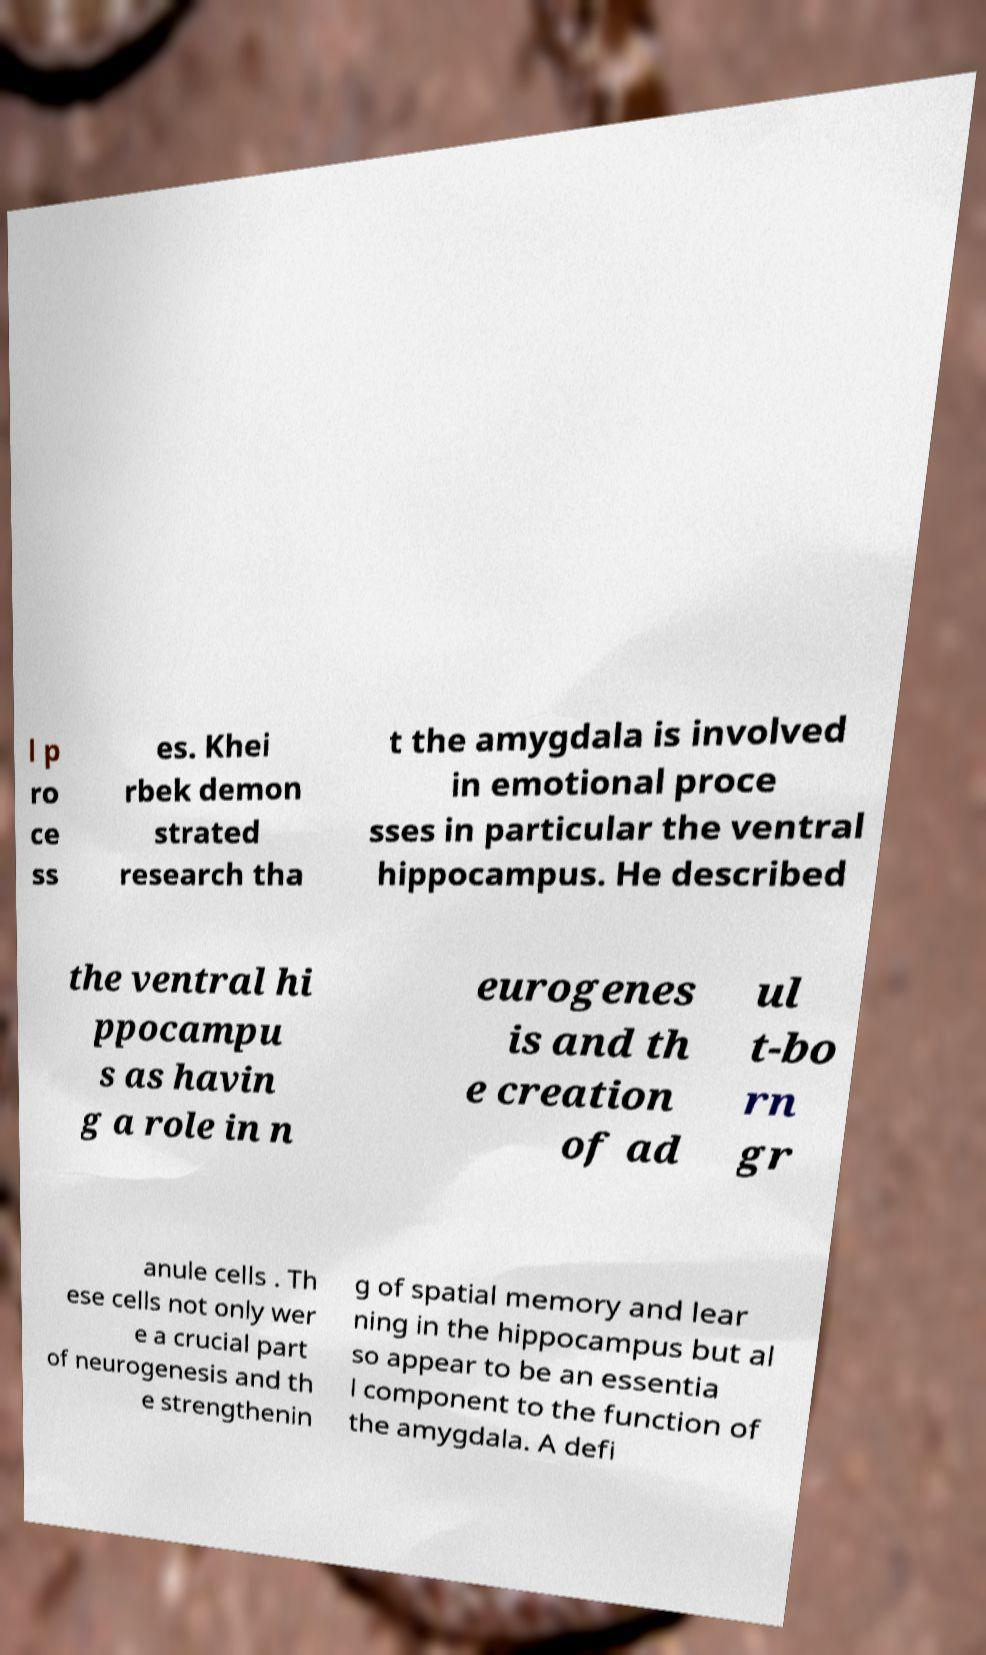Can you read and provide the text displayed in the image?This photo seems to have some interesting text. Can you extract and type it out for me? l p ro ce ss es. Khei rbek demon strated research tha t the amygdala is involved in emotional proce sses in particular the ventral hippocampus. He described the ventral hi ppocampu s as havin g a role in n eurogenes is and th e creation of ad ul t-bo rn gr anule cells . Th ese cells not only wer e a crucial part of neurogenesis and th e strengthenin g of spatial memory and lear ning in the hippocampus but al so appear to be an essentia l component to the function of the amygdala. A defi 